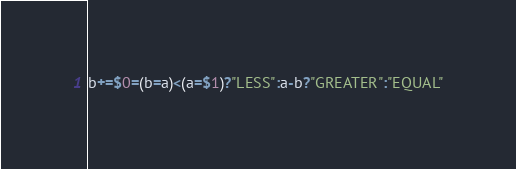Convert code to text. <code><loc_0><loc_0><loc_500><loc_500><_Awk_>b+=$0=(b=a)<(a=$1)?"LESS":a-b?"GREATER":"EQUAL"</code> 